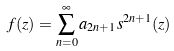<formula> <loc_0><loc_0><loc_500><loc_500>f ( z ) = \sum _ { n = 0 } ^ { \infty } a _ { 2 n + 1 } s ^ { 2 n + 1 } ( z )</formula> 